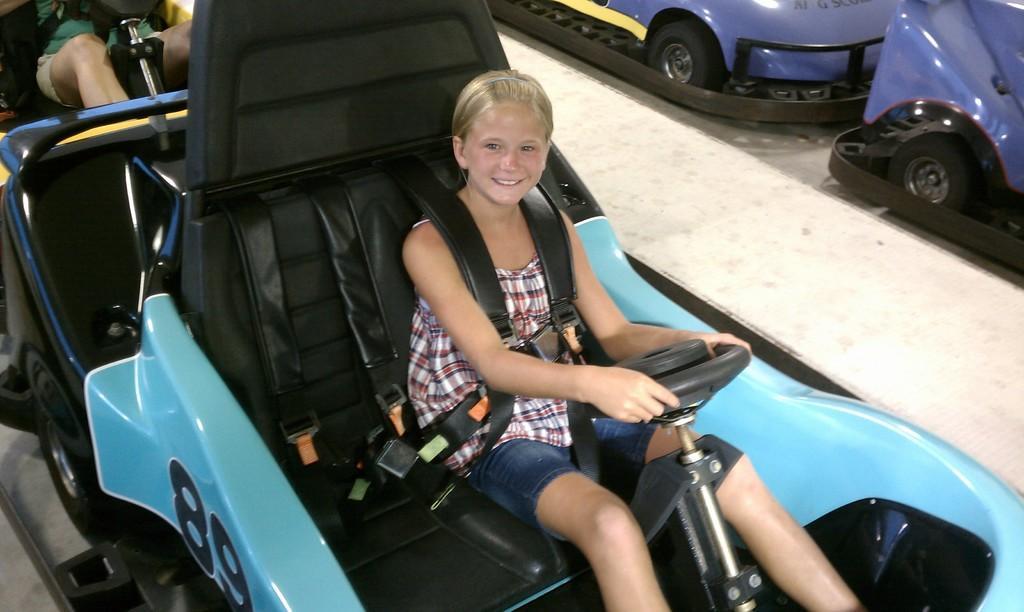Could you give a brief overview of what you see in this image? In this image I can see few rides and here I can see two persons are sitting. I can also smile on her face and here I can see something is written. 